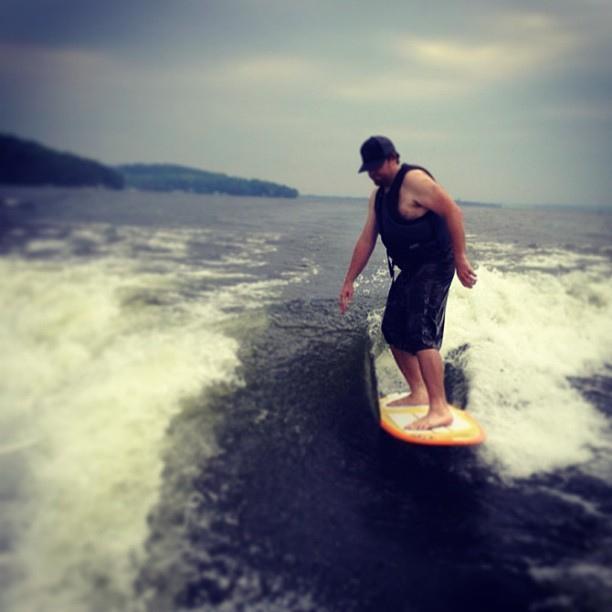How many pieces of sandwich are there?
Give a very brief answer. 0. 